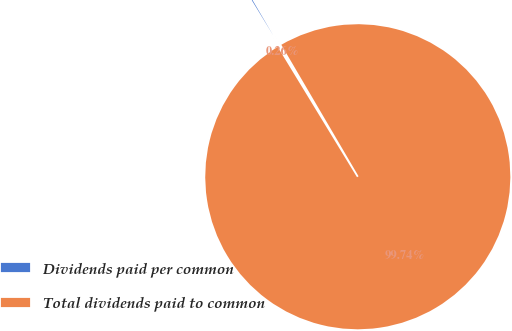Convert chart. <chart><loc_0><loc_0><loc_500><loc_500><pie_chart><fcel>Dividends paid per common<fcel>Total dividends paid to common<nl><fcel>0.26%<fcel>99.74%<nl></chart> 